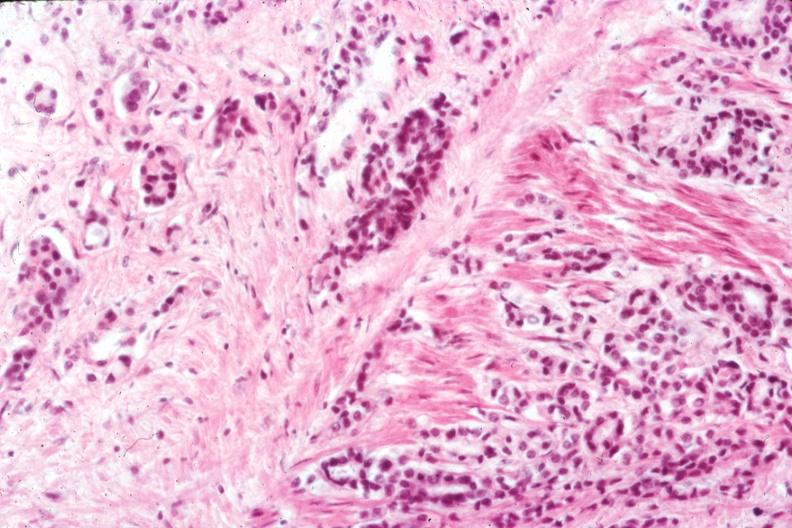what is present?
Answer the question using a single word or phrase. Prostate 